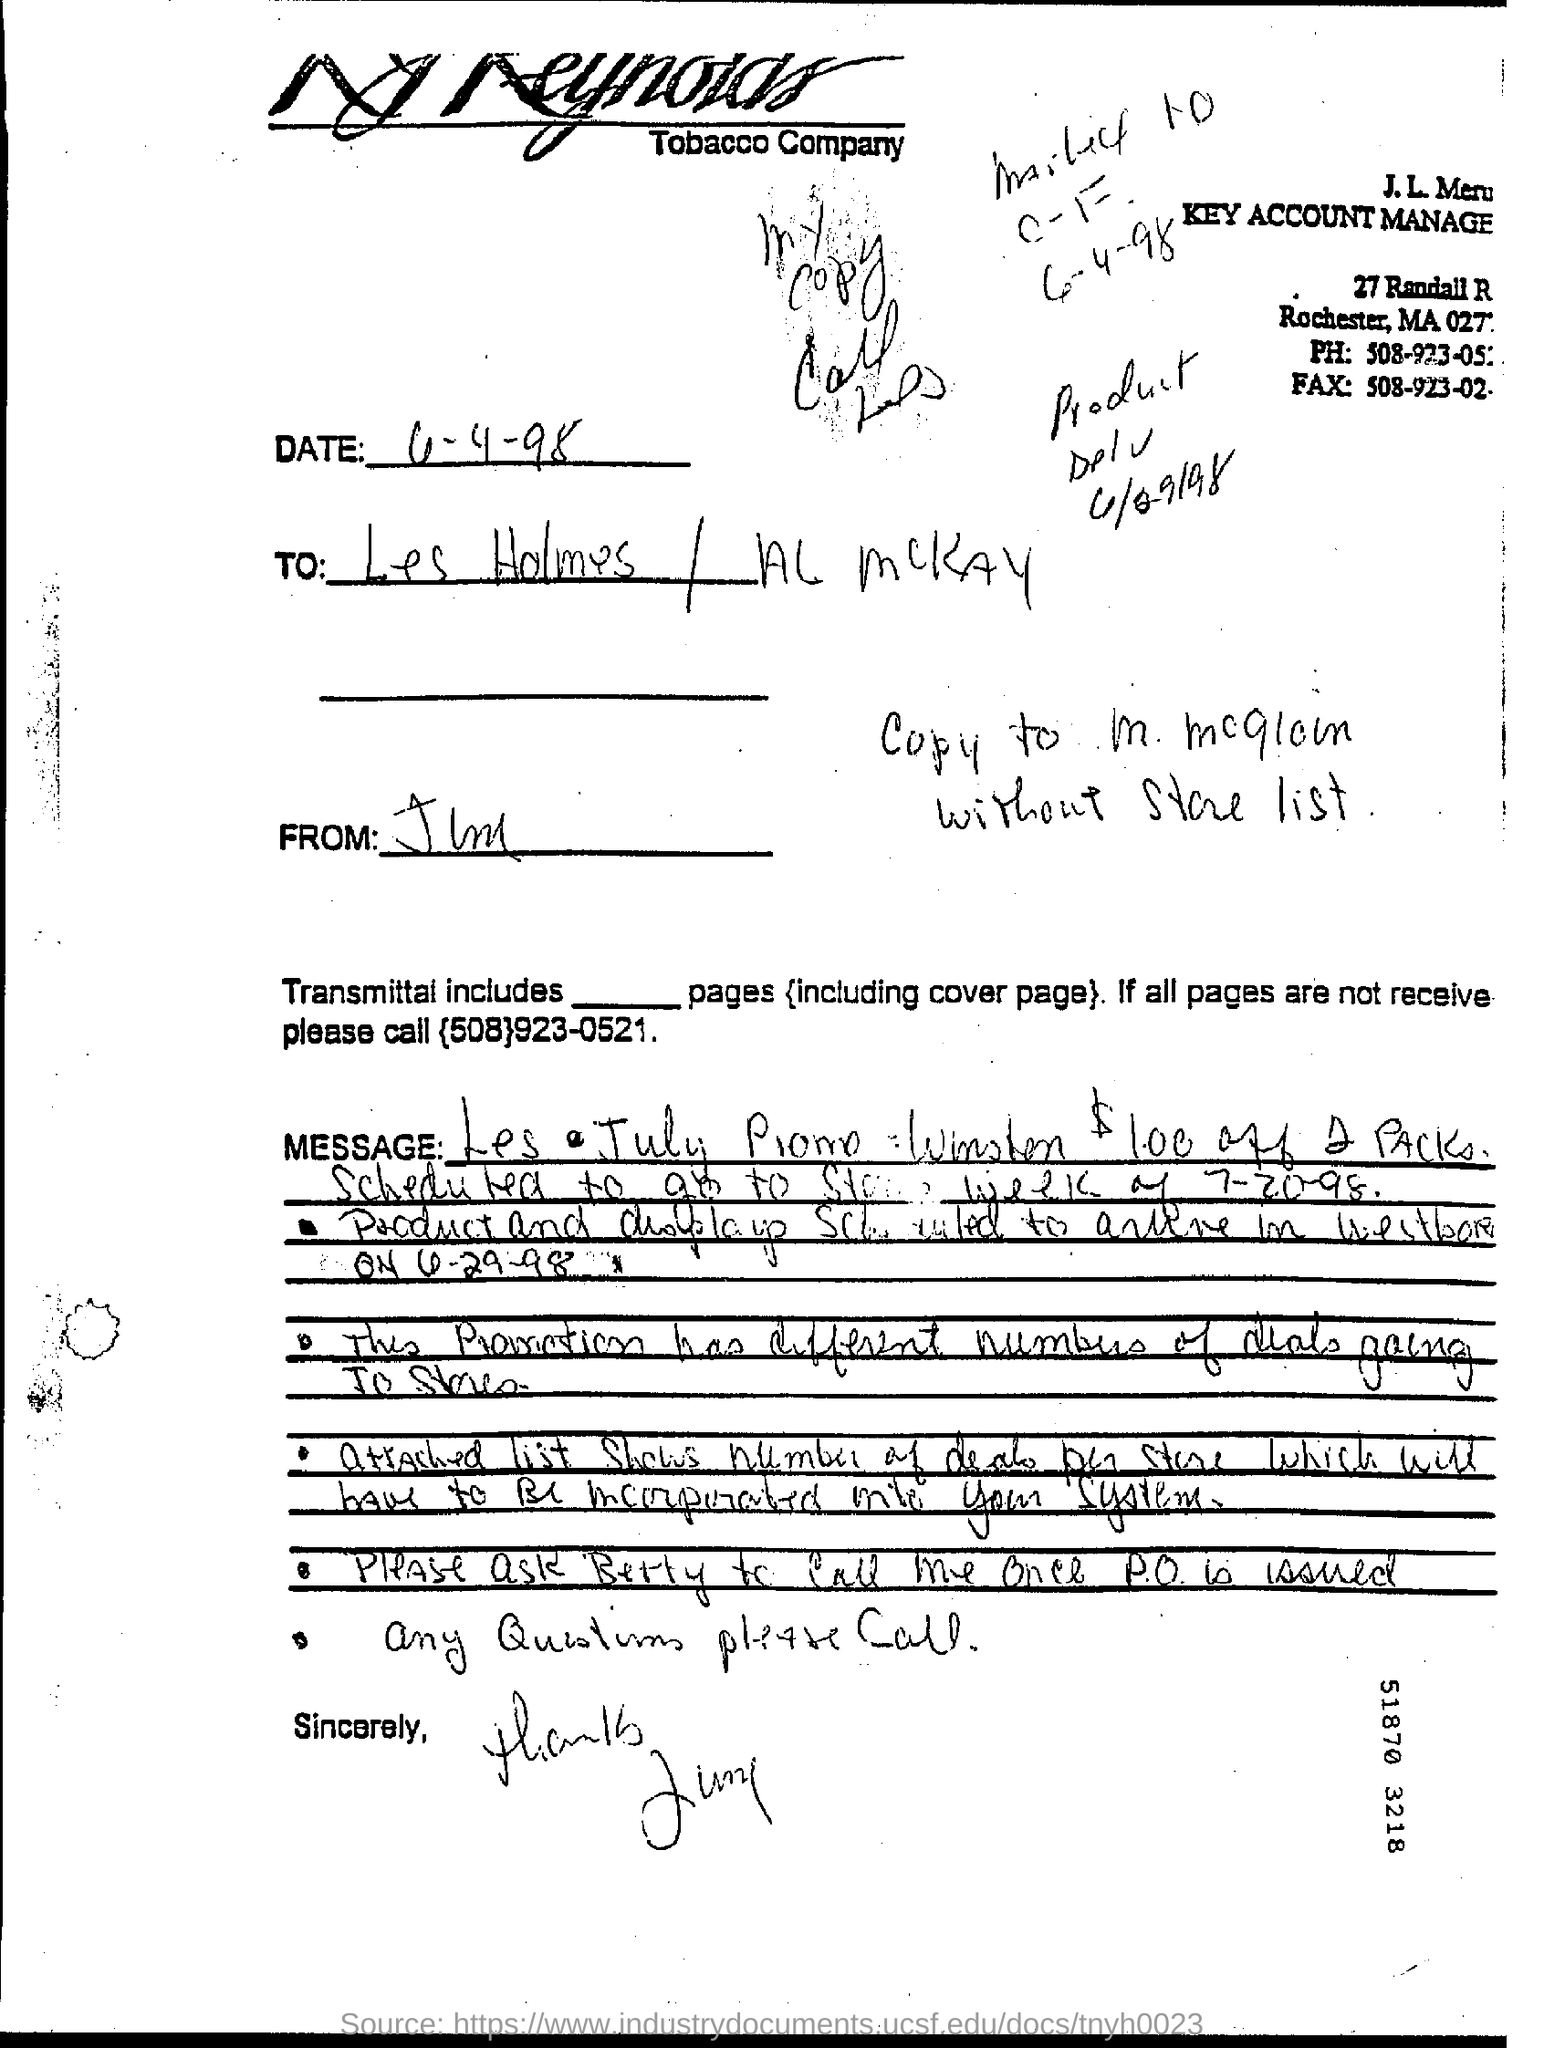Indicate a few pertinent items in this graphic. The line written just above 'sincerely' is 'any questions please call.' 